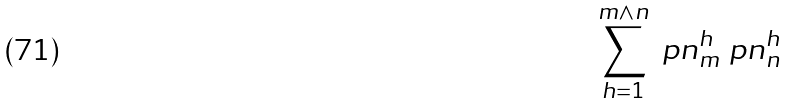Convert formula to latex. <formula><loc_0><loc_0><loc_500><loc_500>\sum _ { h = 1 } ^ { m \wedge n } \ p n ^ { h } _ { m } \ p n ^ { h } _ { n }</formula> 